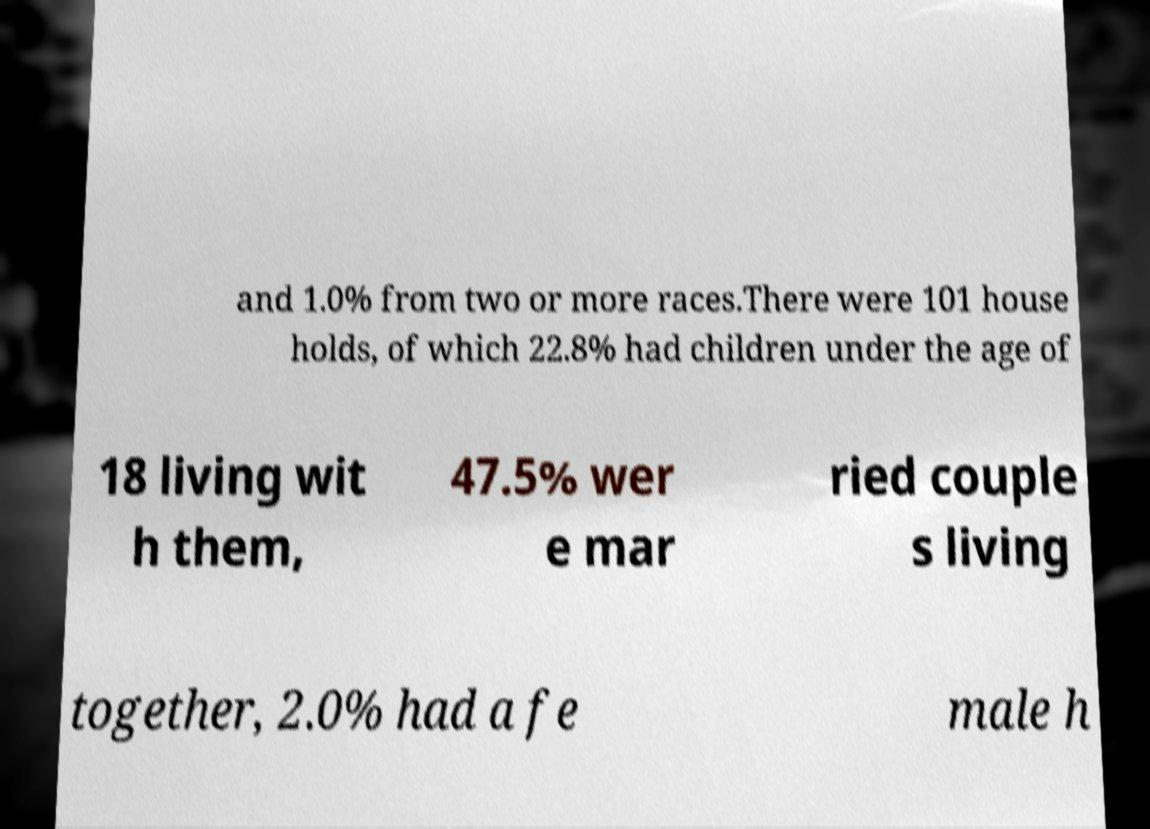I need the written content from this picture converted into text. Can you do that? and 1.0% from two or more races.There were 101 house holds, of which 22.8% had children under the age of 18 living wit h them, 47.5% wer e mar ried couple s living together, 2.0% had a fe male h 